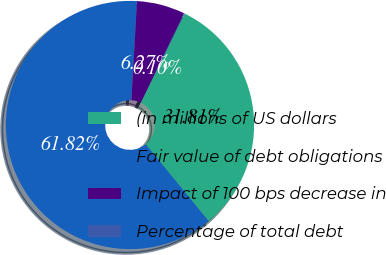<chart> <loc_0><loc_0><loc_500><loc_500><pie_chart><fcel>(in millions of US dollars<fcel>Fair value of debt obligations<fcel>Impact of 100 bps decrease in<fcel>Percentage of total debt<nl><fcel>31.81%<fcel>61.82%<fcel>6.27%<fcel>0.1%<nl></chart> 